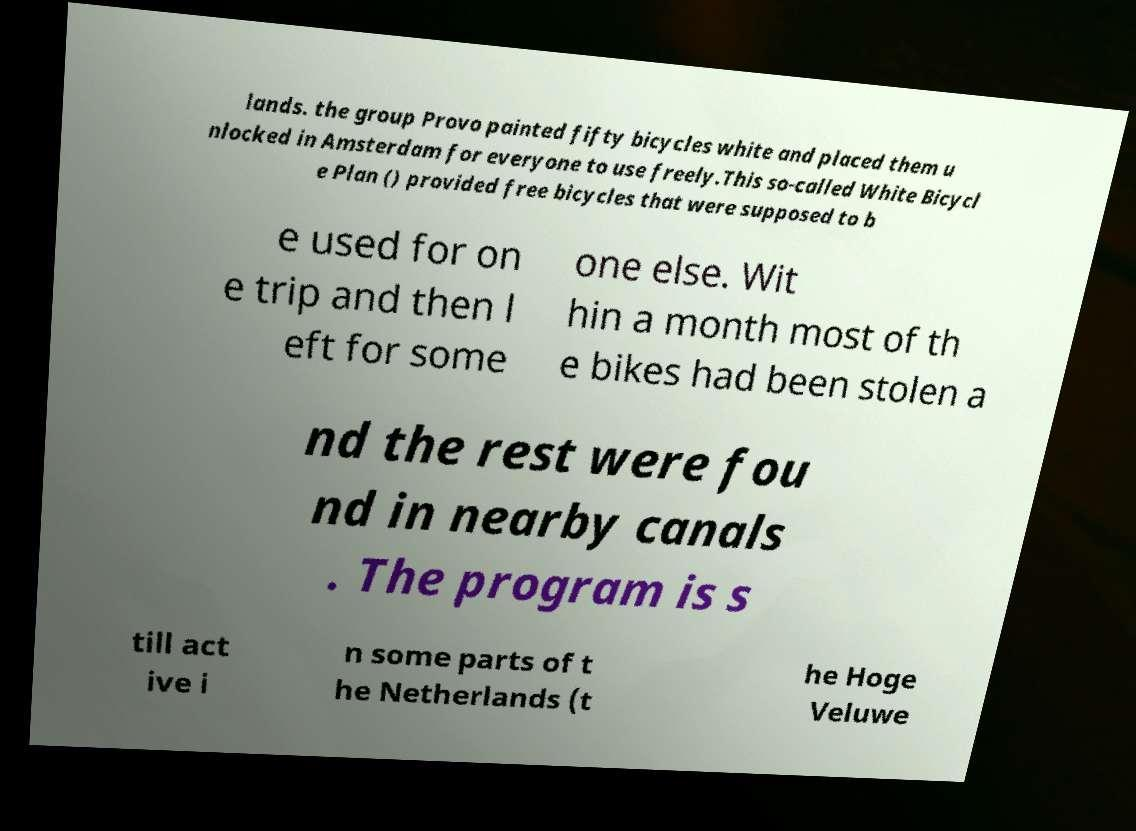Can you accurately transcribe the text from the provided image for me? lands. the group Provo painted fifty bicycles white and placed them u nlocked in Amsterdam for everyone to use freely.This so-called White Bicycl e Plan () provided free bicycles that were supposed to b e used for on e trip and then l eft for some one else. Wit hin a month most of th e bikes had been stolen a nd the rest were fou nd in nearby canals . The program is s till act ive i n some parts of t he Netherlands (t he Hoge Veluwe 